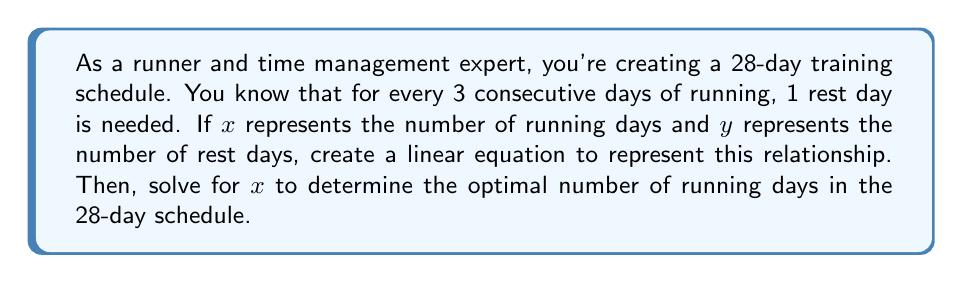Show me your answer to this math problem. Let's approach this step-by-step:

1) First, we need to establish the relationship between running days and rest days:
   For every 3 running days, 1 rest day is needed.
   This can be expressed as: $y = \frac{1}{3}x$

2) We know that the total number of days is 28, so we can write:
   $x + y = 28$

3) Substituting the first equation into the second:
   $x + \frac{1}{3}x = 28$

4) Simplify:
   $\frac{4}{3}x = 28$

5) Multiply both sides by 3:
   $4x = 84$

6) Divide both sides by 4:
   $x = 21$

7) To verify, we can calculate y:
   $y = \frac{1}{3}x = \frac{1}{3}(21) = 7$

8) Check: $21 + 7 = 28$, which confirms our solution.

Therefore, the optimal number of running days in the 28-day schedule is 21 days.
Answer: 21 running days 